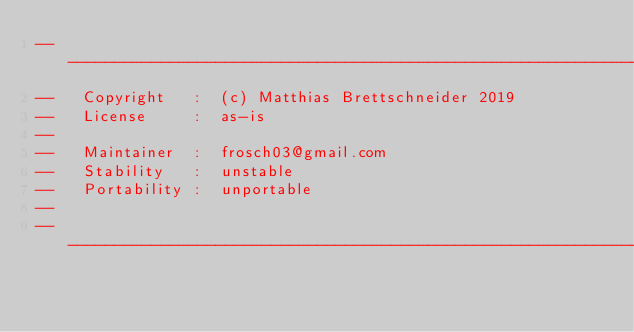<code> <loc_0><loc_0><loc_500><loc_500><_Haskell_>-------------------------------------------------------------------------------
--   Copyright   :  (c) Matthias Brettschneider 2019
--   License     :  as-is
--
--   Maintainer  :  frosch03@gmail.com
--   Stability   :  unstable
--   Portability :  unportable
--
-------------------------------------------------------------------------------

</code> 